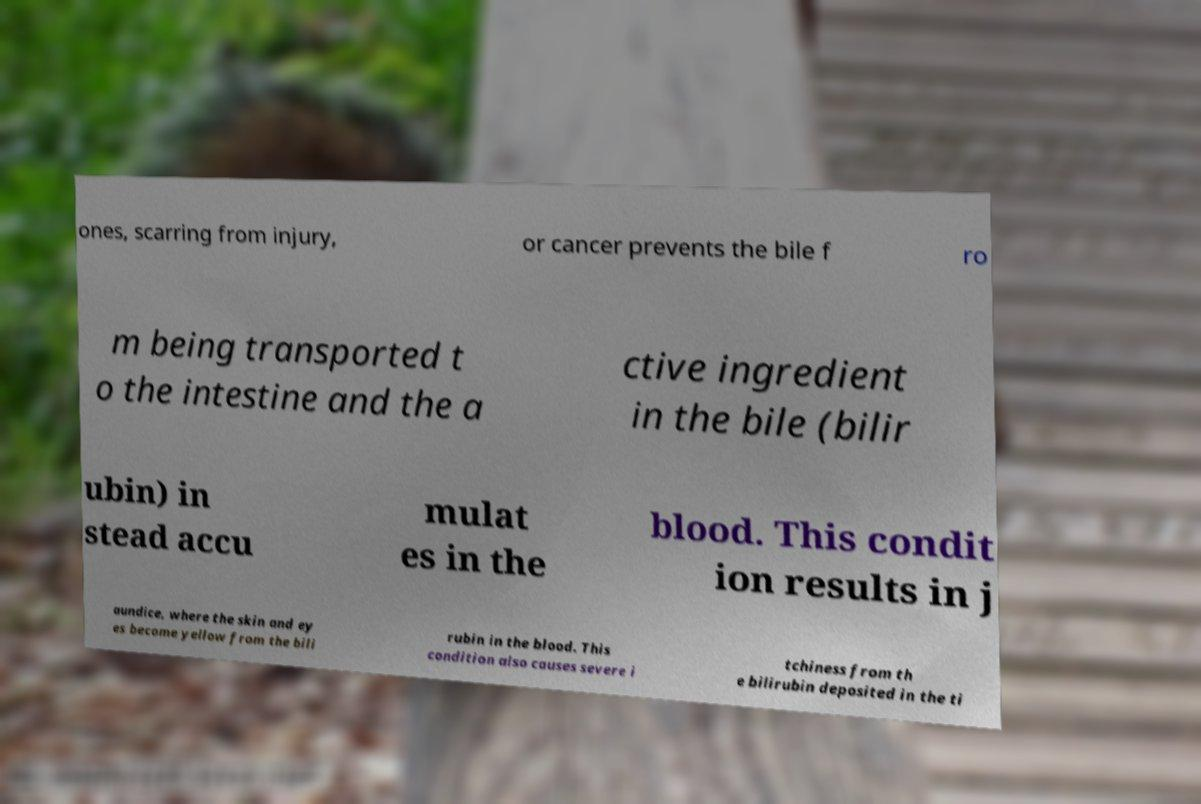Please read and relay the text visible in this image. What does it say? ones, scarring from injury, or cancer prevents the bile f ro m being transported t o the intestine and the a ctive ingredient in the bile (bilir ubin) in stead accu mulat es in the blood. This condit ion results in j aundice, where the skin and ey es become yellow from the bili rubin in the blood. This condition also causes severe i tchiness from th e bilirubin deposited in the ti 